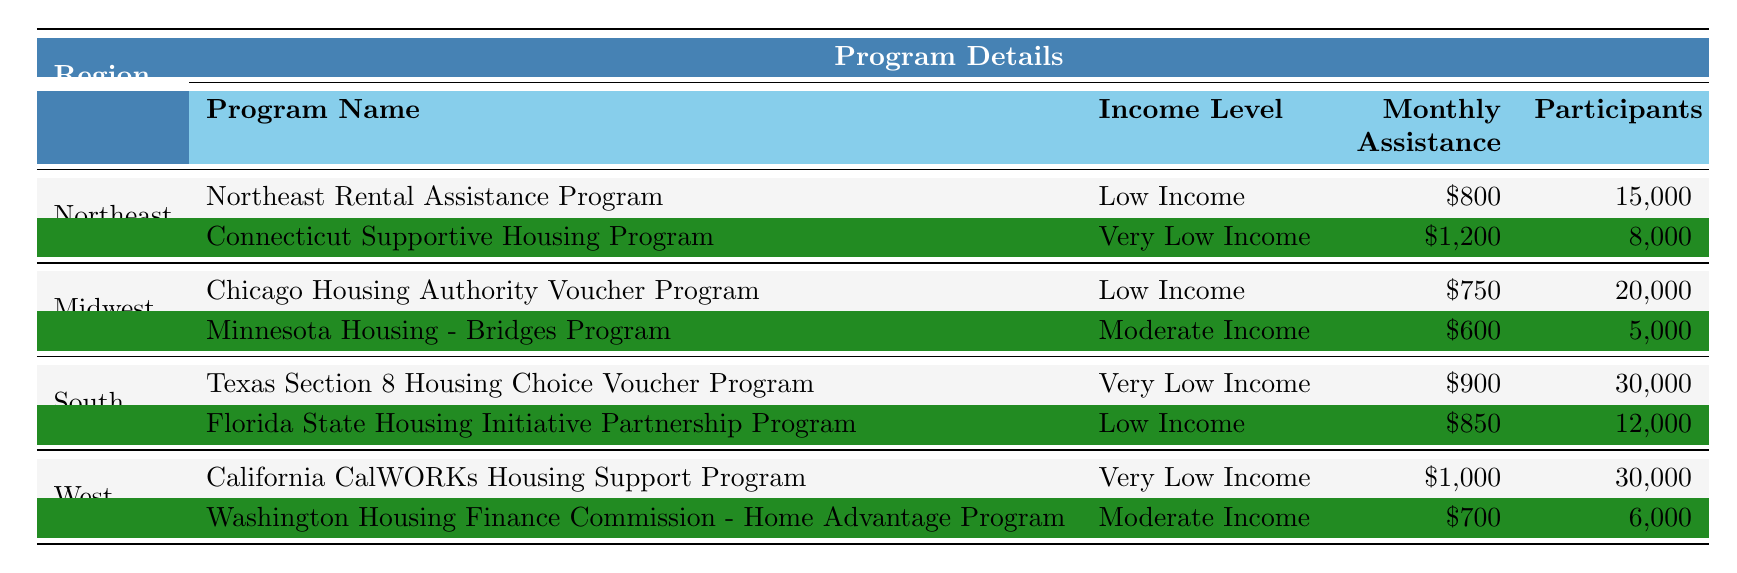What is the monthly assistance provided by the Connecticut Supportive Housing Program? The table lists the Connecticut Supportive Housing Program under the Northeast region, and it states the monthly assistance amount is $1,200.
Answer: $1,200 How many participants are there in the Texas Section 8 Housing Choice Voucher Program? The Texas Section 8 Housing Choice Voucher Program is found in the South region of the table, and it indicates that there are 30,000 participants.
Answer: 30,000 Which program offers the highest monthly assistance in the Northeast region? Looking at the Northeast region, the Connecticut Supportive Housing Program offers $1,200 in monthly assistance, which is the highest compared to the Northeast Rental Assistance Program that offers $800.
Answer: Connecticut Supportive Housing Program What is the combined monthly assistance for all low-income programs listed? In the table, the low-income programs are the Northeast Rental Assistance Program ($800), the Chicago Housing Authority Voucher Program ($750), and the Florida State Housing Initiative Partnership Program ($850). Adding these amounts gives $800 + $750 + $850 = $2,400.
Answer: $2,400 Is there a moderate-income program in the South region? The table shows that the South region only has the Texas Section 8 Housing Choice Voucher Program (very low income) and the Florida State Housing Initiative Partnership Program (low income). There is no moderate-income program listed in the South region.
Answer: No Which region has the highest number of participants across all programs? The table reveals that the Texas Section 8 Housing Choice Voucher Program has the highest participants at 30,000, followed by the Chicago Housing Authority Voucher Program with 20,000, and the Northeast Rental Assistance Program with 15,000. Thus, the South region has the most participants overall.
Answer: South What is the difference in monthly assistance between the lowest and highest moderate-income programs? The table states that the Minnesota Housing - Bridges Program offers $600 for moderate income, and the Washington Housing Finance Commission - Home Advantage Program provides $700. The difference is calculated as $700 - $600 = $100.
Answer: $100 How many programs in the West region offer very low income assistance? According to the table, the West region has two programs: the California CalWORKs Housing Support Program and another program, and both offer very low income assistance.
Answer: 1 Which program in the Midwest region has the lowest number of participants? Referring to the Midwest region, the Minnesota Housing - Bridges Program has the lowest participation at 5,000, while the Chicago Housing Authority Voucher Program has 20,000 participants.
Answer: Minnesota Housing - Bridges Program 